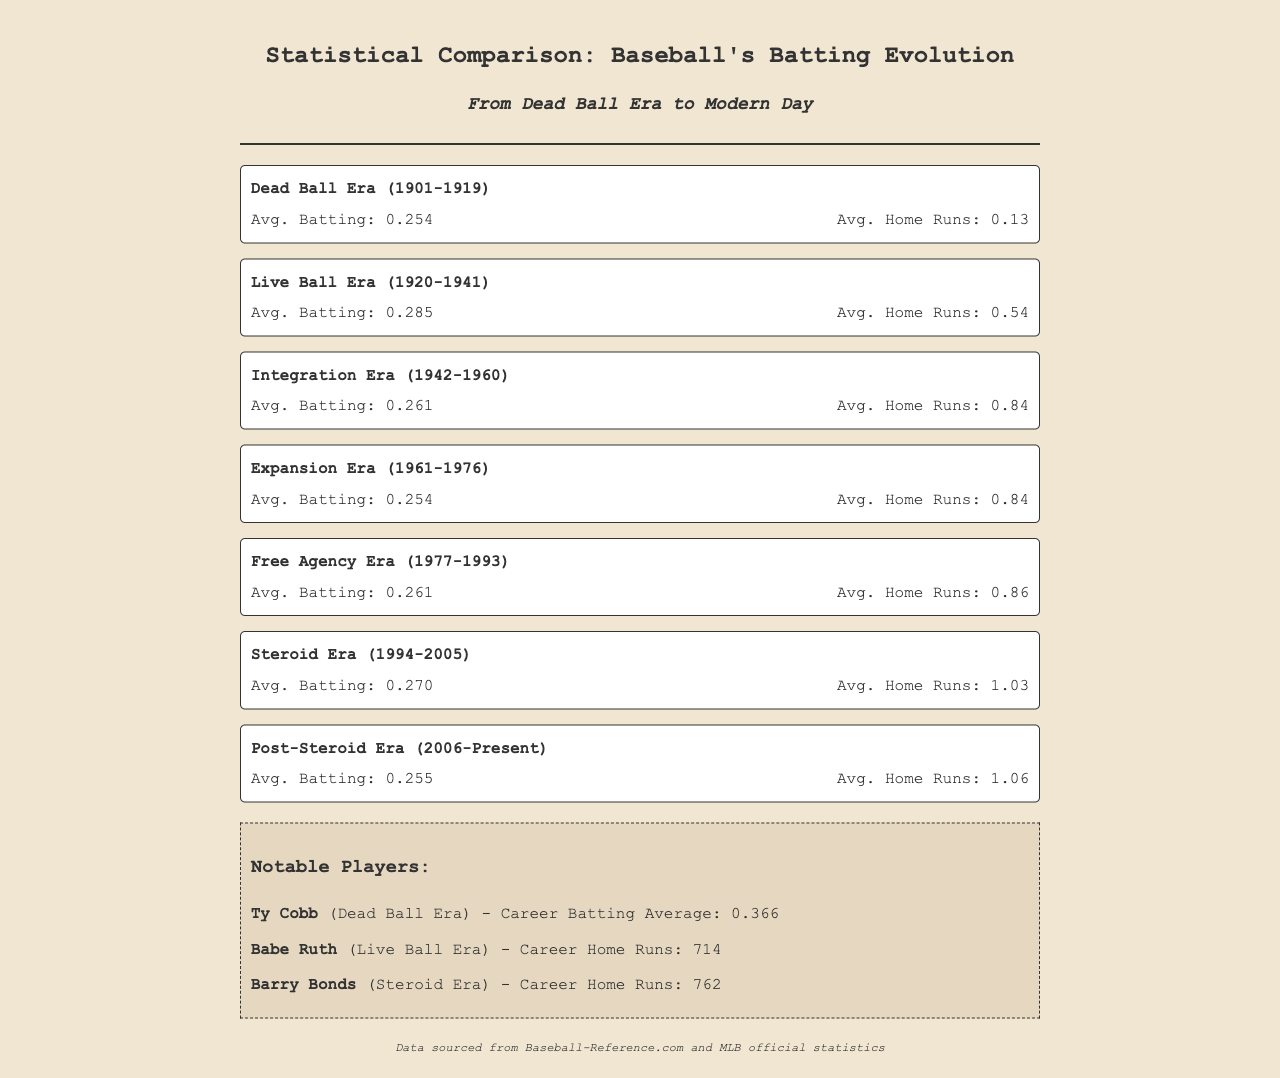What is the average batting for the Dead Ball Era? The average batting for the Dead Ball Era, according to the document, is specifically listed as 0.254.
Answer: 0.254 What is the average number of home runs in the Live Ball Era? The document states that the average number of home runs during the Live Ball Era is 0.54.
Answer: 0.54 Which era had the highest average home runs? By comparing the average home run totals listed, the Steroid Era has the highest average at 1.03.
Answer: 1.03 What is Ty Cobb's career batting average? The document explicitly states that Ty Cobb's career batting average is 0.366.
Answer: 0.366 During which era did Babe Ruth play? The document indicates that Babe Ruth played during the Live Ball Era.
Answer: Live Ball Era How does the average batting of the Post-Steroid Era compare to the Dead Ball Era? The average batting for the Post-Steroid Era is 0.255, which is slightly higher than 0.254 of the Dead Ball Era.
Answer: Slightly higher What are the notable players listed in the fax? The document lists Ty Cobb, Babe Ruth, and Barry Bonds as notable players.
Answer: Ty Cobb, Babe Ruth, Barry Bonds Which era has the same average home runs as the Integration Era? The document shows that both the Integration Era and Expansion Era have the same average home runs of 0.84.
Answer: Expansion Era What is the average batting for the Free Agency Era? The average batting for the Free Agency Era according to the document is 0.261.
Answer: 0.261 